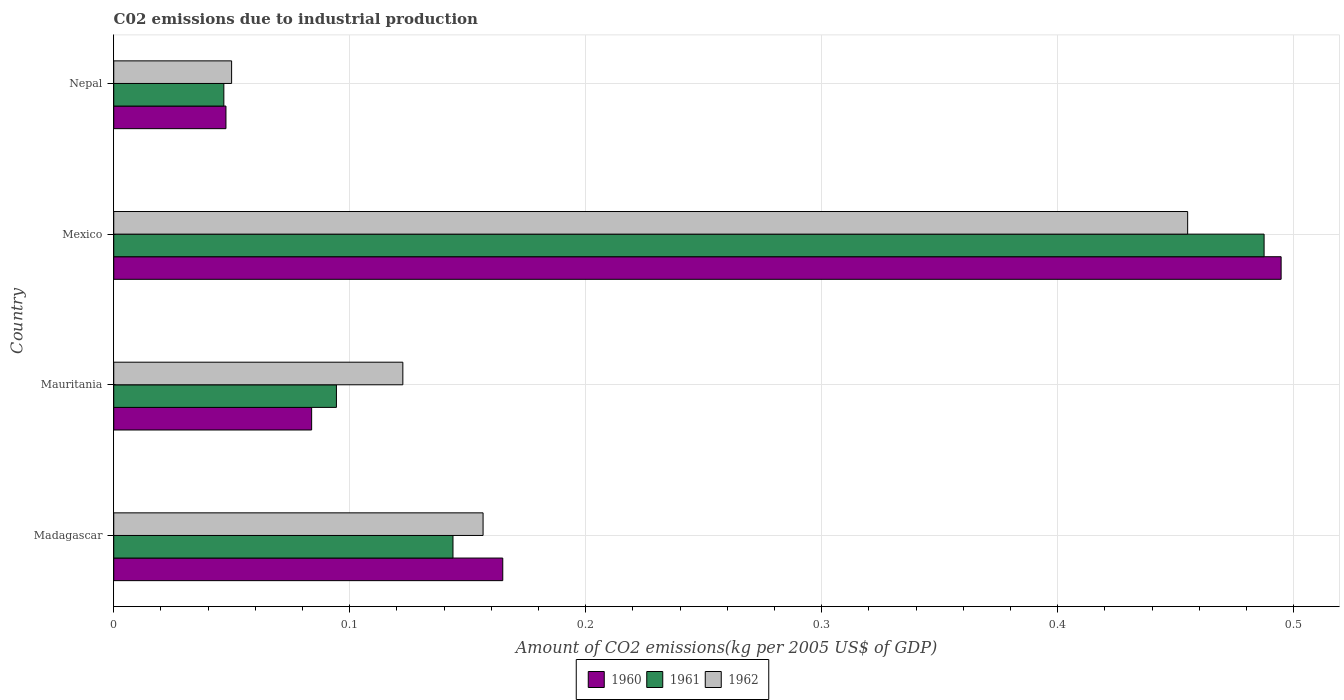How many different coloured bars are there?
Your response must be concise. 3. How many bars are there on the 2nd tick from the top?
Provide a succinct answer. 3. How many bars are there on the 2nd tick from the bottom?
Your answer should be very brief. 3. What is the amount of CO2 emitted due to industrial production in 1960 in Madagascar?
Your response must be concise. 0.16. Across all countries, what is the maximum amount of CO2 emitted due to industrial production in 1961?
Make the answer very short. 0.49. Across all countries, what is the minimum amount of CO2 emitted due to industrial production in 1962?
Your response must be concise. 0.05. In which country was the amount of CO2 emitted due to industrial production in 1961 minimum?
Keep it short and to the point. Nepal. What is the total amount of CO2 emitted due to industrial production in 1961 in the graph?
Ensure brevity in your answer.  0.77. What is the difference between the amount of CO2 emitted due to industrial production in 1960 in Mauritania and that in Mexico?
Your answer should be very brief. -0.41. What is the difference between the amount of CO2 emitted due to industrial production in 1962 in Nepal and the amount of CO2 emitted due to industrial production in 1961 in Madagascar?
Your answer should be very brief. -0.09. What is the average amount of CO2 emitted due to industrial production in 1962 per country?
Your response must be concise. 0.2. What is the difference between the amount of CO2 emitted due to industrial production in 1960 and amount of CO2 emitted due to industrial production in 1962 in Madagascar?
Provide a succinct answer. 0.01. In how many countries, is the amount of CO2 emitted due to industrial production in 1961 greater than 0.24000000000000002 kg?
Your response must be concise. 1. What is the ratio of the amount of CO2 emitted due to industrial production in 1962 in Mauritania to that in Mexico?
Provide a succinct answer. 0.27. Is the amount of CO2 emitted due to industrial production in 1961 in Mexico less than that in Nepal?
Make the answer very short. No. What is the difference between the highest and the second highest amount of CO2 emitted due to industrial production in 1960?
Make the answer very short. 0.33. What is the difference between the highest and the lowest amount of CO2 emitted due to industrial production in 1962?
Give a very brief answer. 0.41. Is it the case that in every country, the sum of the amount of CO2 emitted due to industrial production in 1960 and amount of CO2 emitted due to industrial production in 1961 is greater than the amount of CO2 emitted due to industrial production in 1962?
Provide a short and direct response. Yes. How many bars are there?
Your response must be concise. 12. What is the difference between two consecutive major ticks on the X-axis?
Make the answer very short. 0.1. How are the legend labels stacked?
Ensure brevity in your answer.  Horizontal. What is the title of the graph?
Ensure brevity in your answer.  C02 emissions due to industrial production. What is the label or title of the X-axis?
Offer a terse response. Amount of CO2 emissions(kg per 2005 US$ of GDP). What is the Amount of CO2 emissions(kg per 2005 US$ of GDP) in 1960 in Madagascar?
Make the answer very short. 0.16. What is the Amount of CO2 emissions(kg per 2005 US$ of GDP) of 1961 in Madagascar?
Provide a succinct answer. 0.14. What is the Amount of CO2 emissions(kg per 2005 US$ of GDP) of 1962 in Madagascar?
Provide a succinct answer. 0.16. What is the Amount of CO2 emissions(kg per 2005 US$ of GDP) of 1960 in Mauritania?
Ensure brevity in your answer.  0.08. What is the Amount of CO2 emissions(kg per 2005 US$ of GDP) of 1961 in Mauritania?
Provide a succinct answer. 0.09. What is the Amount of CO2 emissions(kg per 2005 US$ of GDP) in 1962 in Mauritania?
Your answer should be compact. 0.12. What is the Amount of CO2 emissions(kg per 2005 US$ of GDP) in 1960 in Mexico?
Give a very brief answer. 0.49. What is the Amount of CO2 emissions(kg per 2005 US$ of GDP) in 1961 in Mexico?
Ensure brevity in your answer.  0.49. What is the Amount of CO2 emissions(kg per 2005 US$ of GDP) of 1962 in Mexico?
Offer a very short reply. 0.46. What is the Amount of CO2 emissions(kg per 2005 US$ of GDP) in 1960 in Nepal?
Offer a terse response. 0.05. What is the Amount of CO2 emissions(kg per 2005 US$ of GDP) of 1961 in Nepal?
Ensure brevity in your answer.  0.05. What is the Amount of CO2 emissions(kg per 2005 US$ of GDP) of 1962 in Nepal?
Give a very brief answer. 0.05. Across all countries, what is the maximum Amount of CO2 emissions(kg per 2005 US$ of GDP) of 1960?
Provide a short and direct response. 0.49. Across all countries, what is the maximum Amount of CO2 emissions(kg per 2005 US$ of GDP) of 1961?
Make the answer very short. 0.49. Across all countries, what is the maximum Amount of CO2 emissions(kg per 2005 US$ of GDP) of 1962?
Make the answer very short. 0.46. Across all countries, what is the minimum Amount of CO2 emissions(kg per 2005 US$ of GDP) in 1960?
Your answer should be very brief. 0.05. Across all countries, what is the minimum Amount of CO2 emissions(kg per 2005 US$ of GDP) in 1961?
Make the answer very short. 0.05. Across all countries, what is the minimum Amount of CO2 emissions(kg per 2005 US$ of GDP) of 1962?
Keep it short and to the point. 0.05. What is the total Amount of CO2 emissions(kg per 2005 US$ of GDP) in 1960 in the graph?
Your answer should be compact. 0.79. What is the total Amount of CO2 emissions(kg per 2005 US$ of GDP) of 1961 in the graph?
Your answer should be compact. 0.77. What is the total Amount of CO2 emissions(kg per 2005 US$ of GDP) of 1962 in the graph?
Make the answer very short. 0.78. What is the difference between the Amount of CO2 emissions(kg per 2005 US$ of GDP) in 1960 in Madagascar and that in Mauritania?
Offer a terse response. 0.08. What is the difference between the Amount of CO2 emissions(kg per 2005 US$ of GDP) in 1961 in Madagascar and that in Mauritania?
Provide a short and direct response. 0.05. What is the difference between the Amount of CO2 emissions(kg per 2005 US$ of GDP) of 1962 in Madagascar and that in Mauritania?
Give a very brief answer. 0.03. What is the difference between the Amount of CO2 emissions(kg per 2005 US$ of GDP) in 1960 in Madagascar and that in Mexico?
Offer a very short reply. -0.33. What is the difference between the Amount of CO2 emissions(kg per 2005 US$ of GDP) in 1961 in Madagascar and that in Mexico?
Give a very brief answer. -0.34. What is the difference between the Amount of CO2 emissions(kg per 2005 US$ of GDP) of 1962 in Madagascar and that in Mexico?
Keep it short and to the point. -0.3. What is the difference between the Amount of CO2 emissions(kg per 2005 US$ of GDP) in 1960 in Madagascar and that in Nepal?
Offer a very short reply. 0.12. What is the difference between the Amount of CO2 emissions(kg per 2005 US$ of GDP) of 1961 in Madagascar and that in Nepal?
Keep it short and to the point. 0.1. What is the difference between the Amount of CO2 emissions(kg per 2005 US$ of GDP) in 1962 in Madagascar and that in Nepal?
Make the answer very short. 0.11. What is the difference between the Amount of CO2 emissions(kg per 2005 US$ of GDP) in 1960 in Mauritania and that in Mexico?
Offer a terse response. -0.41. What is the difference between the Amount of CO2 emissions(kg per 2005 US$ of GDP) in 1961 in Mauritania and that in Mexico?
Offer a very short reply. -0.39. What is the difference between the Amount of CO2 emissions(kg per 2005 US$ of GDP) of 1962 in Mauritania and that in Mexico?
Offer a terse response. -0.33. What is the difference between the Amount of CO2 emissions(kg per 2005 US$ of GDP) in 1960 in Mauritania and that in Nepal?
Provide a succinct answer. 0.04. What is the difference between the Amount of CO2 emissions(kg per 2005 US$ of GDP) in 1961 in Mauritania and that in Nepal?
Provide a succinct answer. 0.05. What is the difference between the Amount of CO2 emissions(kg per 2005 US$ of GDP) of 1962 in Mauritania and that in Nepal?
Keep it short and to the point. 0.07. What is the difference between the Amount of CO2 emissions(kg per 2005 US$ of GDP) of 1960 in Mexico and that in Nepal?
Provide a short and direct response. 0.45. What is the difference between the Amount of CO2 emissions(kg per 2005 US$ of GDP) in 1961 in Mexico and that in Nepal?
Give a very brief answer. 0.44. What is the difference between the Amount of CO2 emissions(kg per 2005 US$ of GDP) of 1962 in Mexico and that in Nepal?
Your answer should be compact. 0.41. What is the difference between the Amount of CO2 emissions(kg per 2005 US$ of GDP) in 1960 in Madagascar and the Amount of CO2 emissions(kg per 2005 US$ of GDP) in 1961 in Mauritania?
Ensure brevity in your answer.  0.07. What is the difference between the Amount of CO2 emissions(kg per 2005 US$ of GDP) of 1960 in Madagascar and the Amount of CO2 emissions(kg per 2005 US$ of GDP) of 1962 in Mauritania?
Make the answer very short. 0.04. What is the difference between the Amount of CO2 emissions(kg per 2005 US$ of GDP) of 1961 in Madagascar and the Amount of CO2 emissions(kg per 2005 US$ of GDP) of 1962 in Mauritania?
Your answer should be very brief. 0.02. What is the difference between the Amount of CO2 emissions(kg per 2005 US$ of GDP) of 1960 in Madagascar and the Amount of CO2 emissions(kg per 2005 US$ of GDP) of 1961 in Mexico?
Your answer should be very brief. -0.32. What is the difference between the Amount of CO2 emissions(kg per 2005 US$ of GDP) of 1960 in Madagascar and the Amount of CO2 emissions(kg per 2005 US$ of GDP) of 1962 in Mexico?
Offer a terse response. -0.29. What is the difference between the Amount of CO2 emissions(kg per 2005 US$ of GDP) of 1961 in Madagascar and the Amount of CO2 emissions(kg per 2005 US$ of GDP) of 1962 in Mexico?
Offer a very short reply. -0.31. What is the difference between the Amount of CO2 emissions(kg per 2005 US$ of GDP) of 1960 in Madagascar and the Amount of CO2 emissions(kg per 2005 US$ of GDP) of 1961 in Nepal?
Give a very brief answer. 0.12. What is the difference between the Amount of CO2 emissions(kg per 2005 US$ of GDP) in 1960 in Madagascar and the Amount of CO2 emissions(kg per 2005 US$ of GDP) in 1962 in Nepal?
Your response must be concise. 0.11. What is the difference between the Amount of CO2 emissions(kg per 2005 US$ of GDP) in 1961 in Madagascar and the Amount of CO2 emissions(kg per 2005 US$ of GDP) in 1962 in Nepal?
Your response must be concise. 0.09. What is the difference between the Amount of CO2 emissions(kg per 2005 US$ of GDP) in 1960 in Mauritania and the Amount of CO2 emissions(kg per 2005 US$ of GDP) in 1961 in Mexico?
Make the answer very short. -0.4. What is the difference between the Amount of CO2 emissions(kg per 2005 US$ of GDP) in 1960 in Mauritania and the Amount of CO2 emissions(kg per 2005 US$ of GDP) in 1962 in Mexico?
Your answer should be very brief. -0.37. What is the difference between the Amount of CO2 emissions(kg per 2005 US$ of GDP) of 1961 in Mauritania and the Amount of CO2 emissions(kg per 2005 US$ of GDP) of 1962 in Mexico?
Provide a succinct answer. -0.36. What is the difference between the Amount of CO2 emissions(kg per 2005 US$ of GDP) of 1960 in Mauritania and the Amount of CO2 emissions(kg per 2005 US$ of GDP) of 1961 in Nepal?
Your answer should be very brief. 0.04. What is the difference between the Amount of CO2 emissions(kg per 2005 US$ of GDP) of 1960 in Mauritania and the Amount of CO2 emissions(kg per 2005 US$ of GDP) of 1962 in Nepal?
Offer a terse response. 0.03. What is the difference between the Amount of CO2 emissions(kg per 2005 US$ of GDP) of 1961 in Mauritania and the Amount of CO2 emissions(kg per 2005 US$ of GDP) of 1962 in Nepal?
Your response must be concise. 0.04. What is the difference between the Amount of CO2 emissions(kg per 2005 US$ of GDP) of 1960 in Mexico and the Amount of CO2 emissions(kg per 2005 US$ of GDP) of 1961 in Nepal?
Provide a short and direct response. 0.45. What is the difference between the Amount of CO2 emissions(kg per 2005 US$ of GDP) of 1960 in Mexico and the Amount of CO2 emissions(kg per 2005 US$ of GDP) of 1962 in Nepal?
Provide a succinct answer. 0.44. What is the difference between the Amount of CO2 emissions(kg per 2005 US$ of GDP) of 1961 in Mexico and the Amount of CO2 emissions(kg per 2005 US$ of GDP) of 1962 in Nepal?
Your response must be concise. 0.44. What is the average Amount of CO2 emissions(kg per 2005 US$ of GDP) of 1960 per country?
Provide a short and direct response. 0.2. What is the average Amount of CO2 emissions(kg per 2005 US$ of GDP) in 1961 per country?
Provide a succinct answer. 0.19. What is the average Amount of CO2 emissions(kg per 2005 US$ of GDP) in 1962 per country?
Offer a very short reply. 0.2. What is the difference between the Amount of CO2 emissions(kg per 2005 US$ of GDP) in 1960 and Amount of CO2 emissions(kg per 2005 US$ of GDP) in 1961 in Madagascar?
Offer a very short reply. 0.02. What is the difference between the Amount of CO2 emissions(kg per 2005 US$ of GDP) in 1960 and Amount of CO2 emissions(kg per 2005 US$ of GDP) in 1962 in Madagascar?
Provide a succinct answer. 0.01. What is the difference between the Amount of CO2 emissions(kg per 2005 US$ of GDP) of 1961 and Amount of CO2 emissions(kg per 2005 US$ of GDP) of 1962 in Madagascar?
Offer a terse response. -0.01. What is the difference between the Amount of CO2 emissions(kg per 2005 US$ of GDP) of 1960 and Amount of CO2 emissions(kg per 2005 US$ of GDP) of 1961 in Mauritania?
Keep it short and to the point. -0.01. What is the difference between the Amount of CO2 emissions(kg per 2005 US$ of GDP) in 1960 and Amount of CO2 emissions(kg per 2005 US$ of GDP) in 1962 in Mauritania?
Make the answer very short. -0.04. What is the difference between the Amount of CO2 emissions(kg per 2005 US$ of GDP) of 1961 and Amount of CO2 emissions(kg per 2005 US$ of GDP) of 1962 in Mauritania?
Make the answer very short. -0.03. What is the difference between the Amount of CO2 emissions(kg per 2005 US$ of GDP) of 1960 and Amount of CO2 emissions(kg per 2005 US$ of GDP) of 1961 in Mexico?
Make the answer very short. 0.01. What is the difference between the Amount of CO2 emissions(kg per 2005 US$ of GDP) of 1960 and Amount of CO2 emissions(kg per 2005 US$ of GDP) of 1962 in Mexico?
Offer a very short reply. 0.04. What is the difference between the Amount of CO2 emissions(kg per 2005 US$ of GDP) of 1961 and Amount of CO2 emissions(kg per 2005 US$ of GDP) of 1962 in Mexico?
Offer a terse response. 0.03. What is the difference between the Amount of CO2 emissions(kg per 2005 US$ of GDP) of 1960 and Amount of CO2 emissions(kg per 2005 US$ of GDP) of 1961 in Nepal?
Give a very brief answer. 0. What is the difference between the Amount of CO2 emissions(kg per 2005 US$ of GDP) of 1960 and Amount of CO2 emissions(kg per 2005 US$ of GDP) of 1962 in Nepal?
Your answer should be very brief. -0. What is the difference between the Amount of CO2 emissions(kg per 2005 US$ of GDP) of 1961 and Amount of CO2 emissions(kg per 2005 US$ of GDP) of 1962 in Nepal?
Your answer should be very brief. -0. What is the ratio of the Amount of CO2 emissions(kg per 2005 US$ of GDP) of 1960 in Madagascar to that in Mauritania?
Your answer should be very brief. 1.97. What is the ratio of the Amount of CO2 emissions(kg per 2005 US$ of GDP) of 1961 in Madagascar to that in Mauritania?
Keep it short and to the point. 1.52. What is the ratio of the Amount of CO2 emissions(kg per 2005 US$ of GDP) in 1962 in Madagascar to that in Mauritania?
Offer a terse response. 1.28. What is the ratio of the Amount of CO2 emissions(kg per 2005 US$ of GDP) in 1960 in Madagascar to that in Mexico?
Ensure brevity in your answer.  0.33. What is the ratio of the Amount of CO2 emissions(kg per 2005 US$ of GDP) in 1961 in Madagascar to that in Mexico?
Provide a succinct answer. 0.29. What is the ratio of the Amount of CO2 emissions(kg per 2005 US$ of GDP) in 1962 in Madagascar to that in Mexico?
Your answer should be very brief. 0.34. What is the ratio of the Amount of CO2 emissions(kg per 2005 US$ of GDP) of 1960 in Madagascar to that in Nepal?
Offer a very short reply. 3.47. What is the ratio of the Amount of CO2 emissions(kg per 2005 US$ of GDP) in 1961 in Madagascar to that in Nepal?
Offer a terse response. 3.08. What is the ratio of the Amount of CO2 emissions(kg per 2005 US$ of GDP) of 1962 in Madagascar to that in Nepal?
Make the answer very short. 3.13. What is the ratio of the Amount of CO2 emissions(kg per 2005 US$ of GDP) of 1960 in Mauritania to that in Mexico?
Your answer should be compact. 0.17. What is the ratio of the Amount of CO2 emissions(kg per 2005 US$ of GDP) of 1961 in Mauritania to that in Mexico?
Provide a short and direct response. 0.19. What is the ratio of the Amount of CO2 emissions(kg per 2005 US$ of GDP) in 1962 in Mauritania to that in Mexico?
Offer a terse response. 0.27. What is the ratio of the Amount of CO2 emissions(kg per 2005 US$ of GDP) of 1960 in Mauritania to that in Nepal?
Your answer should be compact. 1.76. What is the ratio of the Amount of CO2 emissions(kg per 2005 US$ of GDP) of 1961 in Mauritania to that in Nepal?
Make the answer very short. 2.02. What is the ratio of the Amount of CO2 emissions(kg per 2005 US$ of GDP) in 1962 in Mauritania to that in Nepal?
Make the answer very short. 2.45. What is the ratio of the Amount of CO2 emissions(kg per 2005 US$ of GDP) of 1960 in Mexico to that in Nepal?
Make the answer very short. 10.4. What is the ratio of the Amount of CO2 emissions(kg per 2005 US$ of GDP) of 1961 in Mexico to that in Nepal?
Offer a terse response. 10.45. What is the ratio of the Amount of CO2 emissions(kg per 2005 US$ of GDP) in 1962 in Mexico to that in Nepal?
Make the answer very short. 9.11. What is the difference between the highest and the second highest Amount of CO2 emissions(kg per 2005 US$ of GDP) in 1960?
Keep it short and to the point. 0.33. What is the difference between the highest and the second highest Amount of CO2 emissions(kg per 2005 US$ of GDP) of 1961?
Keep it short and to the point. 0.34. What is the difference between the highest and the second highest Amount of CO2 emissions(kg per 2005 US$ of GDP) of 1962?
Offer a terse response. 0.3. What is the difference between the highest and the lowest Amount of CO2 emissions(kg per 2005 US$ of GDP) in 1960?
Offer a terse response. 0.45. What is the difference between the highest and the lowest Amount of CO2 emissions(kg per 2005 US$ of GDP) in 1961?
Provide a succinct answer. 0.44. What is the difference between the highest and the lowest Amount of CO2 emissions(kg per 2005 US$ of GDP) in 1962?
Keep it short and to the point. 0.41. 